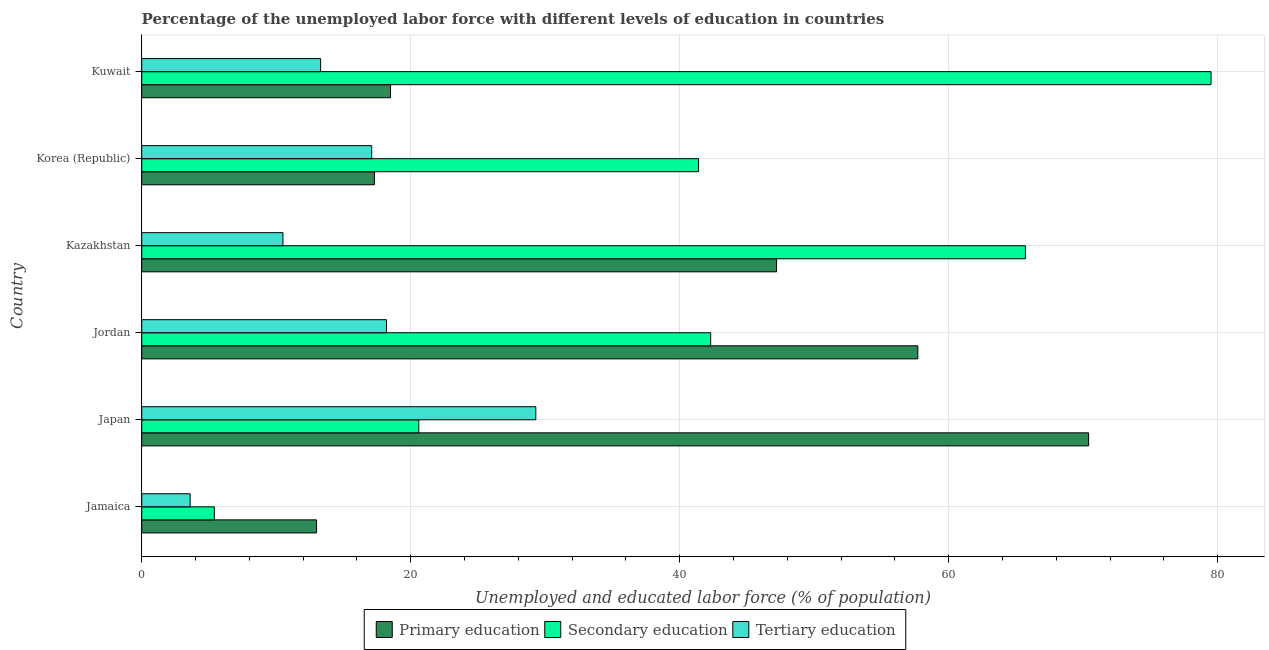How many groups of bars are there?
Provide a succinct answer. 6. Are the number of bars per tick equal to the number of legend labels?
Keep it short and to the point. Yes. What is the label of the 2nd group of bars from the top?
Your response must be concise. Korea (Republic). What is the percentage of labor force who received primary education in Korea (Republic)?
Provide a short and direct response. 17.3. Across all countries, what is the maximum percentage of labor force who received tertiary education?
Make the answer very short. 29.3. Across all countries, what is the minimum percentage of labor force who received secondary education?
Keep it short and to the point. 5.4. In which country was the percentage of labor force who received primary education maximum?
Provide a succinct answer. Japan. In which country was the percentage of labor force who received primary education minimum?
Provide a short and direct response. Jamaica. What is the total percentage of labor force who received tertiary education in the graph?
Make the answer very short. 92. What is the difference between the percentage of labor force who received secondary education in Japan and that in Kazakhstan?
Ensure brevity in your answer.  -45.1. What is the difference between the percentage of labor force who received primary education in Korea (Republic) and the percentage of labor force who received secondary education in Jamaica?
Keep it short and to the point. 11.9. What is the average percentage of labor force who received tertiary education per country?
Your answer should be compact. 15.33. In how many countries, is the percentage of labor force who received primary education greater than 64 %?
Provide a short and direct response. 1. What is the ratio of the percentage of labor force who received primary education in Japan to that in Kuwait?
Your answer should be compact. 3.81. Is the difference between the percentage of labor force who received secondary education in Jordan and Kuwait greater than the difference between the percentage of labor force who received tertiary education in Jordan and Kuwait?
Give a very brief answer. No. What is the difference between the highest and the lowest percentage of labor force who received primary education?
Keep it short and to the point. 57.4. Is the sum of the percentage of labor force who received tertiary education in Japan and Jordan greater than the maximum percentage of labor force who received primary education across all countries?
Ensure brevity in your answer.  No. What does the 2nd bar from the top in Kuwait represents?
Provide a succinct answer. Secondary education. What does the 1st bar from the bottom in Japan represents?
Offer a very short reply. Primary education. How many bars are there?
Provide a short and direct response. 18. Are all the bars in the graph horizontal?
Provide a succinct answer. Yes. How many countries are there in the graph?
Offer a very short reply. 6. What is the difference between two consecutive major ticks on the X-axis?
Make the answer very short. 20. Does the graph contain grids?
Ensure brevity in your answer.  Yes. What is the title of the graph?
Give a very brief answer. Percentage of the unemployed labor force with different levels of education in countries. What is the label or title of the X-axis?
Keep it short and to the point. Unemployed and educated labor force (% of population). What is the label or title of the Y-axis?
Ensure brevity in your answer.  Country. What is the Unemployed and educated labor force (% of population) of Primary education in Jamaica?
Offer a terse response. 13. What is the Unemployed and educated labor force (% of population) in Secondary education in Jamaica?
Your answer should be very brief. 5.4. What is the Unemployed and educated labor force (% of population) in Tertiary education in Jamaica?
Ensure brevity in your answer.  3.6. What is the Unemployed and educated labor force (% of population) of Primary education in Japan?
Offer a very short reply. 70.4. What is the Unemployed and educated labor force (% of population) of Secondary education in Japan?
Your answer should be compact. 20.6. What is the Unemployed and educated labor force (% of population) of Tertiary education in Japan?
Ensure brevity in your answer.  29.3. What is the Unemployed and educated labor force (% of population) of Primary education in Jordan?
Offer a very short reply. 57.7. What is the Unemployed and educated labor force (% of population) in Secondary education in Jordan?
Your answer should be very brief. 42.3. What is the Unemployed and educated labor force (% of population) in Tertiary education in Jordan?
Make the answer very short. 18.2. What is the Unemployed and educated labor force (% of population) of Primary education in Kazakhstan?
Your response must be concise. 47.2. What is the Unemployed and educated labor force (% of population) in Secondary education in Kazakhstan?
Your answer should be very brief. 65.7. What is the Unemployed and educated labor force (% of population) in Tertiary education in Kazakhstan?
Provide a succinct answer. 10.5. What is the Unemployed and educated labor force (% of population) of Primary education in Korea (Republic)?
Offer a very short reply. 17.3. What is the Unemployed and educated labor force (% of population) of Secondary education in Korea (Republic)?
Provide a succinct answer. 41.4. What is the Unemployed and educated labor force (% of population) of Tertiary education in Korea (Republic)?
Provide a succinct answer. 17.1. What is the Unemployed and educated labor force (% of population) in Primary education in Kuwait?
Ensure brevity in your answer.  18.5. What is the Unemployed and educated labor force (% of population) in Secondary education in Kuwait?
Offer a terse response. 79.5. What is the Unemployed and educated labor force (% of population) in Tertiary education in Kuwait?
Keep it short and to the point. 13.3. Across all countries, what is the maximum Unemployed and educated labor force (% of population) of Primary education?
Provide a succinct answer. 70.4. Across all countries, what is the maximum Unemployed and educated labor force (% of population) of Secondary education?
Ensure brevity in your answer.  79.5. Across all countries, what is the maximum Unemployed and educated labor force (% of population) of Tertiary education?
Offer a terse response. 29.3. Across all countries, what is the minimum Unemployed and educated labor force (% of population) of Secondary education?
Make the answer very short. 5.4. Across all countries, what is the minimum Unemployed and educated labor force (% of population) in Tertiary education?
Provide a short and direct response. 3.6. What is the total Unemployed and educated labor force (% of population) in Primary education in the graph?
Give a very brief answer. 224.1. What is the total Unemployed and educated labor force (% of population) in Secondary education in the graph?
Keep it short and to the point. 254.9. What is the total Unemployed and educated labor force (% of population) in Tertiary education in the graph?
Ensure brevity in your answer.  92. What is the difference between the Unemployed and educated labor force (% of population) of Primary education in Jamaica and that in Japan?
Offer a terse response. -57.4. What is the difference between the Unemployed and educated labor force (% of population) in Secondary education in Jamaica and that in Japan?
Keep it short and to the point. -15.2. What is the difference between the Unemployed and educated labor force (% of population) in Tertiary education in Jamaica and that in Japan?
Your response must be concise. -25.7. What is the difference between the Unemployed and educated labor force (% of population) in Primary education in Jamaica and that in Jordan?
Your answer should be very brief. -44.7. What is the difference between the Unemployed and educated labor force (% of population) in Secondary education in Jamaica and that in Jordan?
Provide a short and direct response. -36.9. What is the difference between the Unemployed and educated labor force (% of population) of Tertiary education in Jamaica and that in Jordan?
Keep it short and to the point. -14.6. What is the difference between the Unemployed and educated labor force (% of population) in Primary education in Jamaica and that in Kazakhstan?
Offer a very short reply. -34.2. What is the difference between the Unemployed and educated labor force (% of population) of Secondary education in Jamaica and that in Kazakhstan?
Your answer should be compact. -60.3. What is the difference between the Unemployed and educated labor force (% of population) of Primary education in Jamaica and that in Korea (Republic)?
Your answer should be very brief. -4.3. What is the difference between the Unemployed and educated labor force (% of population) of Secondary education in Jamaica and that in Korea (Republic)?
Make the answer very short. -36. What is the difference between the Unemployed and educated labor force (% of population) in Tertiary education in Jamaica and that in Korea (Republic)?
Make the answer very short. -13.5. What is the difference between the Unemployed and educated labor force (% of population) in Secondary education in Jamaica and that in Kuwait?
Provide a short and direct response. -74.1. What is the difference between the Unemployed and educated labor force (% of population) in Secondary education in Japan and that in Jordan?
Offer a terse response. -21.7. What is the difference between the Unemployed and educated labor force (% of population) in Tertiary education in Japan and that in Jordan?
Offer a very short reply. 11.1. What is the difference between the Unemployed and educated labor force (% of population) of Primary education in Japan and that in Kazakhstan?
Your response must be concise. 23.2. What is the difference between the Unemployed and educated labor force (% of population) of Secondary education in Japan and that in Kazakhstan?
Offer a very short reply. -45.1. What is the difference between the Unemployed and educated labor force (% of population) of Tertiary education in Japan and that in Kazakhstan?
Your answer should be compact. 18.8. What is the difference between the Unemployed and educated labor force (% of population) of Primary education in Japan and that in Korea (Republic)?
Provide a short and direct response. 53.1. What is the difference between the Unemployed and educated labor force (% of population) of Secondary education in Japan and that in Korea (Republic)?
Provide a succinct answer. -20.8. What is the difference between the Unemployed and educated labor force (% of population) in Tertiary education in Japan and that in Korea (Republic)?
Ensure brevity in your answer.  12.2. What is the difference between the Unemployed and educated labor force (% of population) of Primary education in Japan and that in Kuwait?
Keep it short and to the point. 51.9. What is the difference between the Unemployed and educated labor force (% of population) of Secondary education in Japan and that in Kuwait?
Ensure brevity in your answer.  -58.9. What is the difference between the Unemployed and educated labor force (% of population) of Secondary education in Jordan and that in Kazakhstan?
Your answer should be very brief. -23.4. What is the difference between the Unemployed and educated labor force (% of population) in Primary education in Jordan and that in Korea (Republic)?
Ensure brevity in your answer.  40.4. What is the difference between the Unemployed and educated labor force (% of population) in Tertiary education in Jordan and that in Korea (Republic)?
Offer a terse response. 1.1. What is the difference between the Unemployed and educated labor force (% of population) of Primary education in Jordan and that in Kuwait?
Make the answer very short. 39.2. What is the difference between the Unemployed and educated labor force (% of population) in Secondary education in Jordan and that in Kuwait?
Offer a very short reply. -37.2. What is the difference between the Unemployed and educated labor force (% of population) of Tertiary education in Jordan and that in Kuwait?
Provide a succinct answer. 4.9. What is the difference between the Unemployed and educated labor force (% of population) of Primary education in Kazakhstan and that in Korea (Republic)?
Ensure brevity in your answer.  29.9. What is the difference between the Unemployed and educated labor force (% of population) of Secondary education in Kazakhstan and that in Korea (Republic)?
Keep it short and to the point. 24.3. What is the difference between the Unemployed and educated labor force (% of population) in Primary education in Kazakhstan and that in Kuwait?
Ensure brevity in your answer.  28.7. What is the difference between the Unemployed and educated labor force (% of population) in Secondary education in Kazakhstan and that in Kuwait?
Offer a terse response. -13.8. What is the difference between the Unemployed and educated labor force (% of population) of Tertiary education in Kazakhstan and that in Kuwait?
Ensure brevity in your answer.  -2.8. What is the difference between the Unemployed and educated labor force (% of population) in Primary education in Korea (Republic) and that in Kuwait?
Keep it short and to the point. -1.2. What is the difference between the Unemployed and educated labor force (% of population) in Secondary education in Korea (Republic) and that in Kuwait?
Provide a succinct answer. -38.1. What is the difference between the Unemployed and educated labor force (% of population) of Tertiary education in Korea (Republic) and that in Kuwait?
Ensure brevity in your answer.  3.8. What is the difference between the Unemployed and educated labor force (% of population) of Primary education in Jamaica and the Unemployed and educated labor force (% of population) of Secondary education in Japan?
Provide a short and direct response. -7.6. What is the difference between the Unemployed and educated labor force (% of population) of Primary education in Jamaica and the Unemployed and educated labor force (% of population) of Tertiary education in Japan?
Ensure brevity in your answer.  -16.3. What is the difference between the Unemployed and educated labor force (% of population) of Secondary education in Jamaica and the Unemployed and educated labor force (% of population) of Tertiary education in Japan?
Provide a succinct answer. -23.9. What is the difference between the Unemployed and educated labor force (% of population) of Primary education in Jamaica and the Unemployed and educated labor force (% of population) of Secondary education in Jordan?
Offer a terse response. -29.3. What is the difference between the Unemployed and educated labor force (% of population) in Primary education in Jamaica and the Unemployed and educated labor force (% of population) in Secondary education in Kazakhstan?
Make the answer very short. -52.7. What is the difference between the Unemployed and educated labor force (% of population) of Primary education in Jamaica and the Unemployed and educated labor force (% of population) of Tertiary education in Kazakhstan?
Offer a terse response. 2.5. What is the difference between the Unemployed and educated labor force (% of population) in Secondary education in Jamaica and the Unemployed and educated labor force (% of population) in Tertiary education in Kazakhstan?
Provide a succinct answer. -5.1. What is the difference between the Unemployed and educated labor force (% of population) in Primary education in Jamaica and the Unemployed and educated labor force (% of population) in Secondary education in Korea (Republic)?
Provide a succinct answer. -28.4. What is the difference between the Unemployed and educated labor force (% of population) of Primary education in Jamaica and the Unemployed and educated labor force (% of population) of Secondary education in Kuwait?
Offer a very short reply. -66.5. What is the difference between the Unemployed and educated labor force (% of population) of Secondary education in Jamaica and the Unemployed and educated labor force (% of population) of Tertiary education in Kuwait?
Keep it short and to the point. -7.9. What is the difference between the Unemployed and educated labor force (% of population) in Primary education in Japan and the Unemployed and educated labor force (% of population) in Secondary education in Jordan?
Make the answer very short. 28.1. What is the difference between the Unemployed and educated labor force (% of population) of Primary education in Japan and the Unemployed and educated labor force (% of population) of Tertiary education in Jordan?
Give a very brief answer. 52.2. What is the difference between the Unemployed and educated labor force (% of population) in Primary education in Japan and the Unemployed and educated labor force (% of population) in Secondary education in Kazakhstan?
Keep it short and to the point. 4.7. What is the difference between the Unemployed and educated labor force (% of population) of Primary education in Japan and the Unemployed and educated labor force (% of population) of Tertiary education in Kazakhstan?
Your answer should be compact. 59.9. What is the difference between the Unemployed and educated labor force (% of population) in Secondary education in Japan and the Unemployed and educated labor force (% of population) in Tertiary education in Kazakhstan?
Make the answer very short. 10.1. What is the difference between the Unemployed and educated labor force (% of population) in Primary education in Japan and the Unemployed and educated labor force (% of population) in Tertiary education in Korea (Republic)?
Offer a terse response. 53.3. What is the difference between the Unemployed and educated labor force (% of population) in Secondary education in Japan and the Unemployed and educated labor force (% of population) in Tertiary education in Korea (Republic)?
Keep it short and to the point. 3.5. What is the difference between the Unemployed and educated labor force (% of population) of Primary education in Japan and the Unemployed and educated labor force (% of population) of Tertiary education in Kuwait?
Ensure brevity in your answer.  57.1. What is the difference between the Unemployed and educated labor force (% of population) in Secondary education in Japan and the Unemployed and educated labor force (% of population) in Tertiary education in Kuwait?
Offer a terse response. 7.3. What is the difference between the Unemployed and educated labor force (% of population) of Primary education in Jordan and the Unemployed and educated labor force (% of population) of Tertiary education in Kazakhstan?
Keep it short and to the point. 47.2. What is the difference between the Unemployed and educated labor force (% of population) in Secondary education in Jordan and the Unemployed and educated labor force (% of population) in Tertiary education in Kazakhstan?
Ensure brevity in your answer.  31.8. What is the difference between the Unemployed and educated labor force (% of population) of Primary education in Jordan and the Unemployed and educated labor force (% of population) of Tertiary education in Korea (Republic)?
Provide a short and direct response. 40.6. What is the difference between the Unemployed and educated labor force (% of population) in Secondary education in Jordan and the Unemployed and educated labor force (% of population) in Tertiary education in Korea (Republic)?
Give a very brief answer. 25.2. What is the difference between the Unemployed and educated labor force (% of population) of Primary education in Jordan and the Unemployed and educated labor force (% of population) of Secondary education in Kuwait?
Offer a terse response. -21.8. What is the difference between the Unemployed and educated labor force (% of population) of Primary education in Jordan and the Unemployed and educated labor force (% of population) of Tertiary education in Kuwait?
Provide a succinct answer. 44.4. What is the difference between the Unemployed and educated labor force (% of population) in Secondary education in Jordan and the Unemployed and educated labor force (% of population) in Tertiary education in Kuwait?
Your answer should be very brief. 29. What is the difference between the Unemployed and educated labor force (% of population) in Primary education in Kazakhstan and the Unemployed and educated labor force (% of population) in Secondary education in Korea (Republic)?
Make the answer very short. 5.8. What is the difference between the Unemployed and educated labor force (% of population) in Primary education in Kazakhstan and the Unemployed and educated labor force (% of population) in Tertiary education in Korea (Republic)?
Give a very brief answer. 30.1. What is the difference between the Unemployed and educated labor force (% of population) of Secondary education in Kazakhstan and the Unemployed and educated labor force (% of population) of Tertiary education in Korea (Republic)?
Your answer should be very brief. 48.6. What is the difference between the Unemployed and educated labor force (% of population) of Primary education in Kazakhstan and the Unemployed and educated labor force (% of population) of Secondary education in Kuwait?
Give a very brief answer. -32.3. What is the difference between the Unemployed and educated labor force (% of population) of Primary education in Kazakhstan and the Unemployed and educated labor force (% of population) of Tertiary education in Kuwait?
Your answer should be very brief. 33.9. What is the difference between the Unemployed and educated labor force (% of population) of Secondary education in Kazakhstan and the Unemployed and educated labor force (% of population) of Tertiary education in Kuwait?
Ensure brevity in your answer.  52.4. What is the difference between the Unemployed and educated labor force (% of population) of Primary education in Korea (Republic) and the Unemployed and educated labor force (% of population) of Secondary education in Kuwait?
Provide a succinct answer. -62.2. What is the difference between the Unemployed and educated labor force (% of population) in Secondary education in Korea (Republic) and the Unemployed and educated labor force (% of population) in Tertiary education in Kuwait?
Your answer should be very brief. 28.1. What is the average Unemployed and educated labor force (% of population) in Primary education per country?
Provide a short and direct response. 37.35. What is the average Unemployed and educated labor force (% of population) in Secondary education per country?
Keep it short and to the point. 42.48. What is the average Unemployed and educated labor force (% of population) of Tertiary education per country?
Ensure brevity in your answer.  15.33. What is the difference between the Unemployed and educated labor force (% of population) of Primary education and Unemployed and educated labor force (% of population) of Secondary education in Jamaica?
Your answer should be very brief. 7.6. What is the difference between the Unemployed and educated labor force (% of population) in Primary education and Unemployed and educated labor force (% of population) in Tertiary education in Jamaica?
Keep it short and to the point. 9.4. What is the difference between the Unemployed and educated labor force (% of population) of Primary education and Unemployed and educated labor force (% of population) of Secondary education in Japan?
Ensure brevity in your answer.  49.8. What is the difference between the Unemployed and educated labor force (% of population) of Primary education and Unemployed and educated labor force (% of population) of Tertiary education in Japan?
Your answer should be compact. 41.1. What is the difference between the Unemployed and educated labor force (% of population) in Primary education and Unemployed and educated labor force (% of population) in Secondary education in Jordan?
Give a very brief answer. 15.4. What is the difference between the Unemployed and educated labor force (% of population) in Primary education and Unemployed and educated labor force (% of population) in Tertiary education in Jordan?
Give a very brief answer. 39.5. What is the difference between the Unemployed and educated labor force (% of population) in Secondary education and Unemployed and educated labor force (% of population) in Tertiary education in Jordan?
Your answer should be compact. 24.1. What is the difference between the Unemployed and educated labor force (% of population) in Primary education and Unemployed and educated labor force (% of population) in Secondary education in Kazakhstan?
Your answer should be very brief. -18.5. What is the difference between the Unemployed and educated labor force (% of population) in Primary education and Unemployed and educated labor force (% of population) in Tertiary education in Kazakhstan?
Your answer should be very brief. 36.7. What is the difference between the Unemployed and educated labor force (% of population) in Secondary education and Unemployed and educated labor force (% of population) in Tertiary education in Kazakhstan?
Ensure brevity in your answer.  55.2. What is the difference between the Unemployed and educated labor force (% of population) in Primary education and Unemployed and educated labor force (% of population) in Secondary education in Korea (Republic)?
Keep it short and to the point. -24.1. What is the difference between the Unemployed and educated labor force (% of population) in Primary education and Unemployed and educated labor force (% of population) in Tertiary education in Korea (Republic)?
Ensure brevity in your answer.  0.2. What is the difference between the Unemployed and educated labor force (% of population) of Secondary education and Unemployed and educated labor force (% of population) of Tertiary education in Korea (Republic)?
Keep it short and to the point. 24.3. What is the difference between the Unemployed and educated labor force (% of population) in Primary education and Unemployed and educated labor force (% of population) in Secondary education in Kuwait?
Provide a short and direct response. -61. What is the difference between the Unemployed and educated labor force (% of population) in Secondary education and Unemployed and educated labor force (% of population) in Tertiary education in Kuwait?
Make the answer very short. 66.2. What is the ratio of the Unemployed and educated labor force (% of population) of Primary education in Jamaica to that in Japan?
Make the answer very short. 0.18. What is the ratio of the Unemployed and educated labor force (% of population) of Secondary education in Jamaica to that in Japan?
Provide a short and direct response. 0.26. What is the ratio of the Unemployed and educated labor force (% of population) of Tertiary education in Jamaica to that in Japan?
Make the answer very short. 0.12. What is the ratio of the Unemployed and educated labor force (% of population) in Primary education in Jamaica to that in Jordan?
Your answer should be compact. 0.23. What is the ratio of the Unemployed and educated labor force (% of population) of Secondary education in Jamaica to that in Jordan?
Provide a succinct answer. 0.13. What is the ratio of the Unemployed and educated labor force (% of population) of Tertiary education in Jamaica to that in Jordan?
Provide a short and direct response. 0.2. What is the ratio of the Unemployed and educated labor force (% of population) of Primary education in Jamaica to that in Kazakhstan?
Make the answer very short. 0.28. What is the ratio of the Unemployed and educated labor force (% of population) of Secondary education in Jamaica to that in Kazakhstan?
Give a very brief answer. 0.08. What is the ratio of the Unemployed and educated labor force (% of population) in Tertiary education in Jamaica to that in Kazakhstan?
Offer a terse response. 0.34. What is the ratio of the Unemployed and educated labor force (% of population) in Primary education in Jamaica to that in Korea (Republic)?
Provide a short and direct response. 0.75. What is the ratio of the Unemployed and educated labor force (% of population) of Secondary education in Jamaica to that in Korea (Republic)?
Your answer should be very brief. 0.13. What is the ratio of the Unemployed and educated labor force (% of population) in Tertiary education in Jamaica to that in Korea (Republic)?
Your response must be concise. 0.21. What is the ratio of the Unemployed and educated labor force (% of population) in Primary education in Jamaica to that in Kuwait?
Offer a very short reply. 0.7. What is the ratio of the Unemployed and educated labor force (% of population) in Secondary education in Jamaica to that in Kuwait?
Provide a succinct answer. 0.07. What is the ratio of the Unemployed and educated labor force (% of population) in Tertiary education in Jamaica to that in Kuwait?
Your answer should be very brief. 0.27. What is the ratio of the Unemployed and educated labor force (% of population) of Primary education in Japan to that in Jordan?
Offer a terse response. 1.22. What is the ratio of the Unemployed and educated labor force (% of population) of Secondary education in Japan to that in Jordan?
Offer a very short reply. 0.49. What is the ratio of the Unemployed and educated labor force (% of population) in Tertiary education in Japan to that in Jordan?
Ensure brevity in your answer.  1.61. What is the ratio of the Unemployed and educated labor force (% of population) in Primary education in Japan to that in Kazakhstan?
Keep it short and to the point. 1.49. What is the ratio of the Unemployed and educated labor force (% of population) of Secondary education in Japan to that in Kazakhstan?
Offer a very short reply. 0.31. What is the ratio of the Unemployed and educated labor force (% of population) in Tertiary education in Japan to that in Kazakhstan?
Your response must be concise. 2.79. What is the ratio of the Unemployed and educated labor force (% of population) of Primary education in Japan to that in Korea (Republic)?
Offer a terse response. 4.07. What is the ratio of the Unemployed and educated labor force (% of population) in Secondary education in Japan to that in Korea (Republic)?
Keep it short and to the point. 0.5. What is the ratio of the Unemployed and educated labor force (% of population) in Tertiary education in Japan to that in Korea (Republic)?
Ensure brevity in your answer.  1.71. What is the ratio of the Unemployed and educated labor force (% of population) of Primary education in Japan to that in Kuwait?
Keep it short and to the point. 3.81. What is the ratio of the Unemployed and educated labor force (% of population) in Secondary education in Japan to that in Kuwait?
Give a very brief answer. 0.26. What is the ratio of the Unemployed and educated labor force (% of population) of Tertiary education in Japan to that in Kuwait?
Make the answer very short. 2.2. What is the ratio of the Unemployed and educated labor force (% of population) in Primary education in Jordan to that in Kazakhstan?
Provide a succinct answer. 1.22. What is the ratio of the Unemployed and educated labor force (% of population) in Secondary education in Jordan to that in Kazakhstan?
Give a very brief answer. 0.64. What is the ratio of the Unemployed and educated labor force (% of population) in Tertiary education in Jordan to that in Kazakhstan?
Offer a terse response. 1.73. What is the ratio of the Unemployed and educated labor force (% of population) of Primary education in Jordan to that in Korea (Republic)?
Keep it short and to the point. 3.34. What is the ratio of the Unemployed and educated labor force (% of population) in Secondary education in Jordan to that in Korea (Republic)?
Offer a very short reply. 1.02. What is the ratio of the Unemployed and educated labor force (% of population) of Tertiary education in Jordan to that in Korea (Republic)?
Provide a short and direct response. 1.06. What is the ratio of the Unemployed and educated labor force (% of population) in Primary education in Jordan to that in Kuwait?
Give a very brief answer. 3.12. What is the ratio of the Unemployed and educated labor force (% of population) in Secondary education in Jordan to that in Kuwait?
Give a very brief answer. 0.53. What is the ratio of the Unemployed and educated labor force (% of population) in Tertiary education in Jordan to that in Kuwait?
Ensure brevity in your answer.  1.37. What is the ratio of the Unemployed and educated labor force (% of population) of Primary education in Kazakhstan to that in Korea (Republic)?
Your answer should be very brief. 2.73. What is the ratio of the Unemployed and educated labor force (% of population) in Secondary education in Kazakhstan to that in Korea (Republic)?
Offer a very short reply. 1.59. What is the ratio of the Unemployed and educated labor force (% of population) in Tertiary education in Kazakhstan to that in Korea (Republic)?
Provide a succinct answer. 0.61. What is the ratio of the Unemployed and educated labor force (% of population) in Primary education in Kazakhstan to that in Kuwait?
Give a very brief answer. 2.55. What is the ratio of the Unemployed and educated labor force (% of population) of Secondary education in Kazakhstan to that in Kuwait?
Your answer should be compact. 0.83. What is the ratio of the Unemployed and educated labor force (% of population) of Tertiary education in Kazakhstan to that in Kuwait?
Make the answer very short. 0.79. What is the ratio of the Unemployed and educated labor force (% of population) in Primary education in Korea (Republic) to that in Kuwait?
Provide a short and direct response. 0.94. What is the ratio of the Unemployed and educated labor force (% of population) of Secondary education in Korea (Republic) to that in Kuwait?
Your answer should be compact. 0.52. What is the ratio of the Unemployed and educated labor force (% of population) in Tertiary education in Korea (Republic) to that in Kuwait?
Offer a terse response. 1.29. What is the difference between the highest and the lowest Unemployed and educated labor force (% of population) of Primary education?
Offer a very short reply. 57.4. What is the difference between the highest and the lowest Unemployed and educated labor force (% of population) of Secondary education?
Ensure brevity in your answer.  74.1. What is the difference between the highest and the lowest Unemployed and educated labor force (% of population) in Tertiary education?
Give a very brief answer. 25.7. 